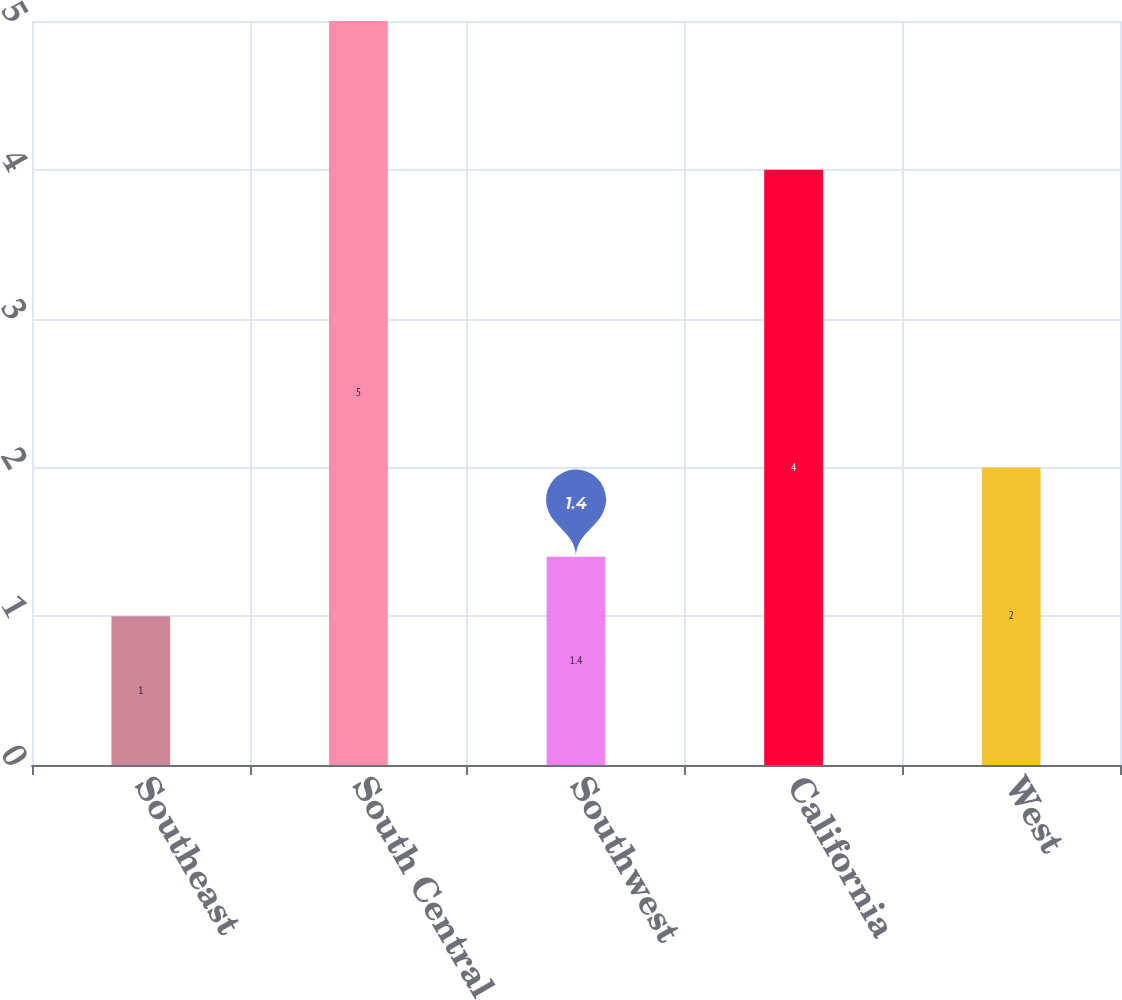Convert chart. <chart><loc_0><loc_0><loc_500><loc_500><bar_chart><fcel>Southeast<fcel>South Central<fcel>Southwest<fcel>California<fcel>West<nl><fcel>1<fcel>5<fcel>1.4<fcel>4<fcel>2<nl></chart> 